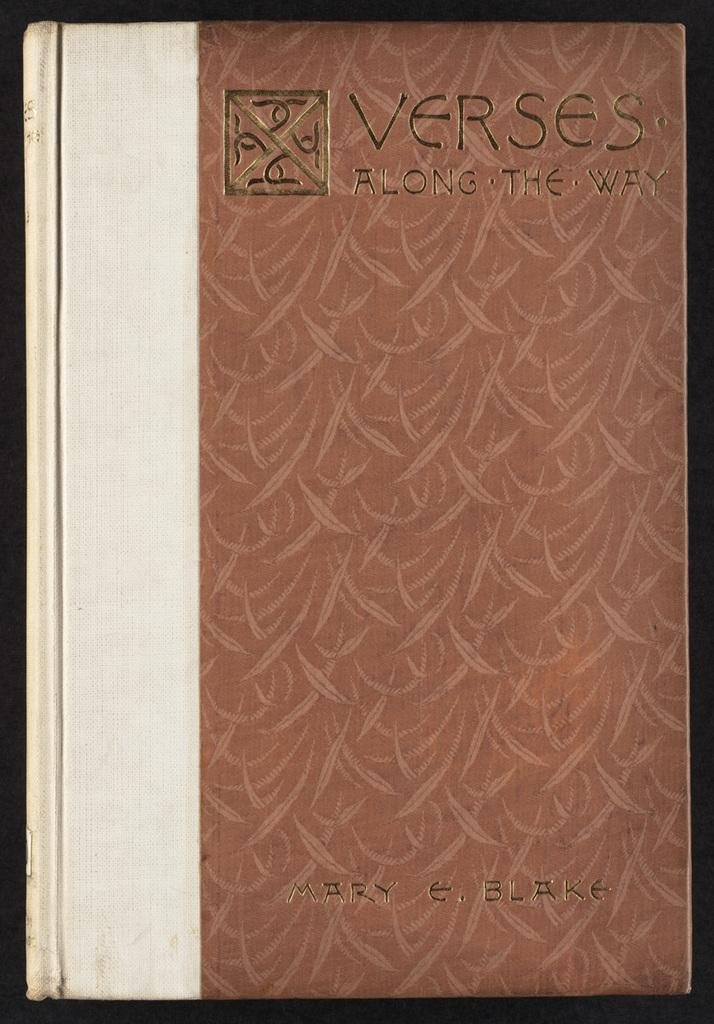<image>
Provide a brief description of the given image. Verses along the way by Mary Blake chapter book. 